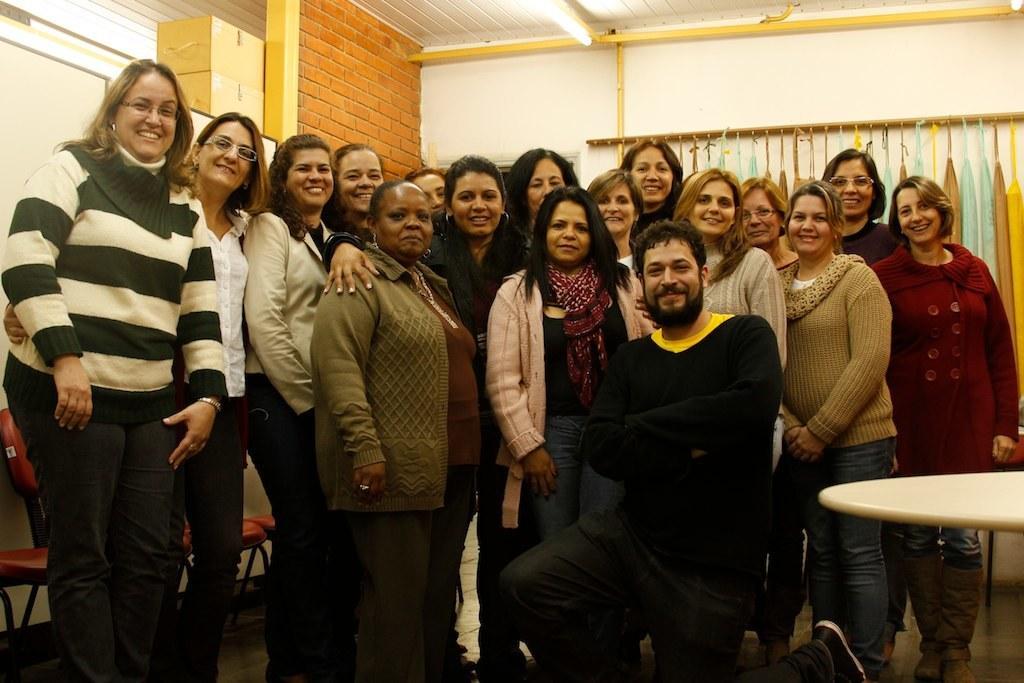Please provide a concise description of this image. In this picture we can see a group of people standing on the floor, and at back here is the wall made of bricks, and here is the roof and here is the light ,and here are the umbrellas and here is the table. 